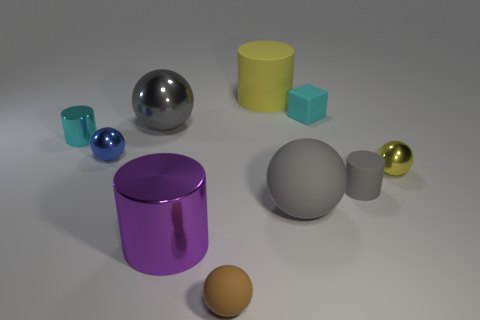Are there more tiny rubber things behind the gray metal thing than small cyan metallic objects?
Give a very brief answer. No. What number of objects are tiny rubber things to the right of the brown rubber object or small blue objects?
Provide a short and direct response. 3. How many brown objects have the same material as the small gray cylinder?
Your response must be concise. 1. There is a large matte object that is the same color as the big metallic ball; what shape is it?
Offer a very short reply. Sphere. Is there a big brown thing that has the same shape as the small brown object?
Your response must be concise. No. The gray metal thing that is the same size as the yellow cylinder is what shape?
Give a very brief answer. Sphere. Is the color of the big rubber ball the same as the metal cylinder on the right side of the small blue shiny sphere?
Your answer should be compact. No. There is a tiny cyan metal thing that is behind the big rubber ball; what number of large gray shiny objects are left of it?
Keep it short and to the point. 0. There is a cylinder that is in front of the small cyan matte thing and on the right side of the brown matte sphere; how big is it?
Make the answer very short. Small. Are there any gray rubber balls of the same size as the purple metal cylinder?
Your answer should be compact. Yes. 